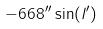<formula> <loc_0><loc_0><loc_500><loc_500>- 6 6 8 ^ { \prime \prime } \sin ( l ^ { \prime } )</formula> 